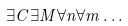Convert formula to latex. <formula><loc_0><loc_0><loc_500><loc_500>\exists C \exists M \forall n \forall m \dots</formula> 